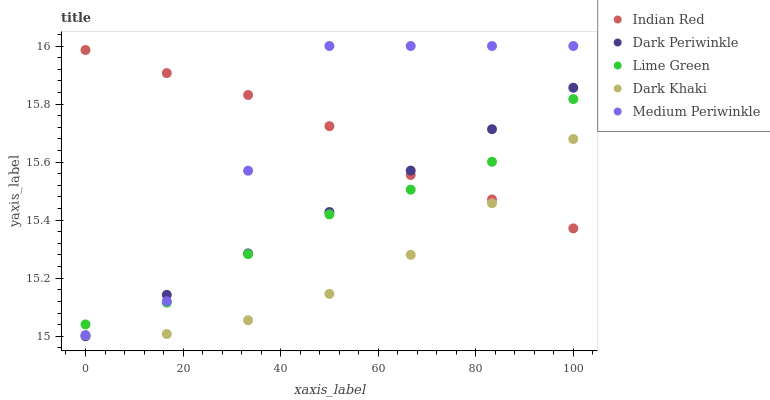Does Dark Khaki have the minimum area under the curve?
Answer yes or no. Yes. Does Medium Periwinkle have the maximum area under the curve?
Answer yes or no. Yes. Does Lime Green have the minimum area under the curve?
Answer yes or no. No. Does Lime Green have the maximum area under the curve?
Answer yes or no. No. Is Dark Periwinkle the smoothest?
Answer yes or no. Yes. Is Medium Periwinkle the roughest?
Answer yes or no. Yes. Is Lime Green the smoothest?
Answer yes or no. No. Is Lime Green the roughest?
Answer yes or no. No. Does Dark Periwinkle have the lowest value?
Answer yes or no. Yes. Does Medium Periwinkle have the lowest value?
Answer yes or no. No. Does Medium Periwinkle have the highest value?
Answer yes or no. Yes. Does Lime Green have the highest value?
Answer yes or no. No. Is Dark Khaki less than Medium Periwinkle?
Answer yes or no. Yes. Is Lime Green greater than Dark Khaki?
Answer yes or no. Yes. Does Dark Khaki intersect Dark Periwinkle?
Answer yes or no. Yes. Is Dark Khaki less than Dark Periwinkle?
Answer yes or no. No. Is Dark Khaki greater than Dark Periwinkle?
Answer yes or no. No. Does Dark Khaki intersect Medium Periwinkle?
Answer yes or no. No. 